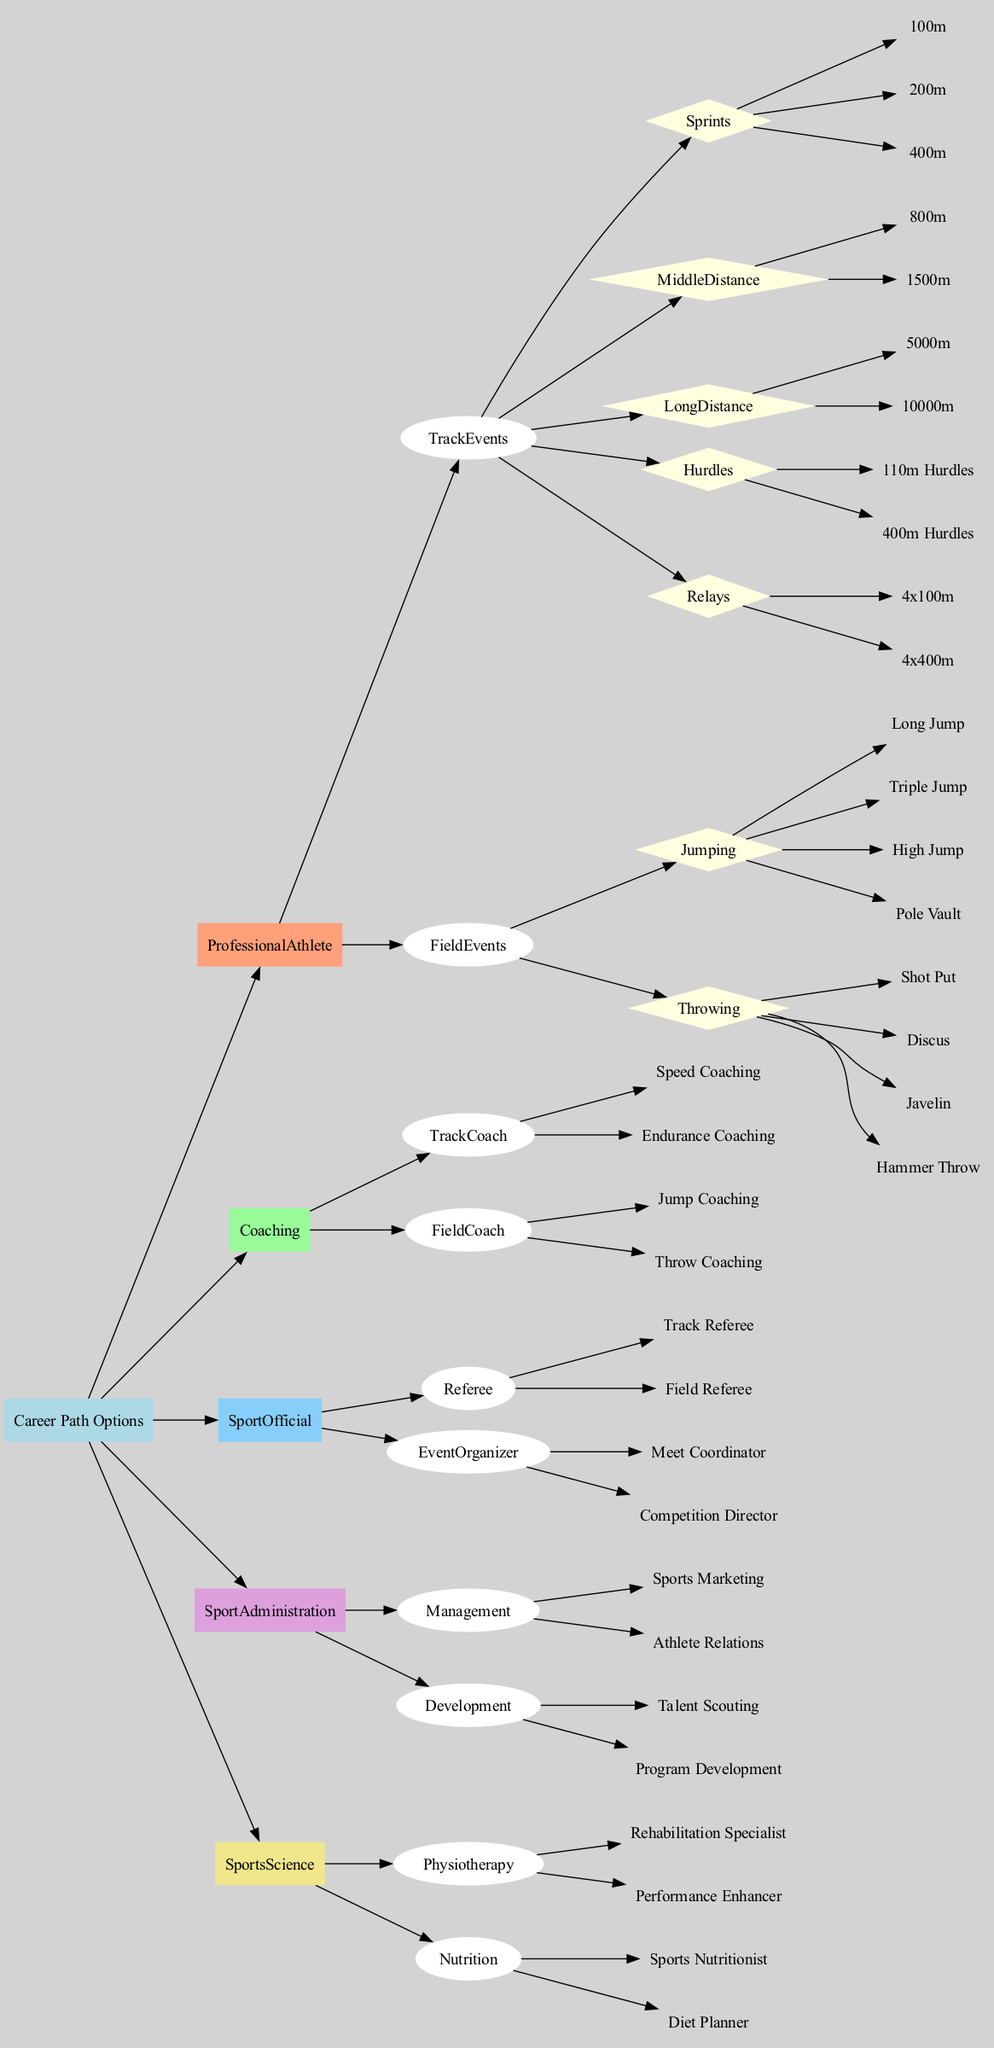What are the two main categories under Coaching? The diagram shows that under Coaching, there are two main subcategories: TrackCoach and FieldCoach. These relate to the type of coaching offered, focusing on track events and field events respectively.
Answer: TrackCoach, FieldCoach How many types of Professional Athlete events are listed? The diagram shows that Professional Athletes can participate in Track Events and Field Events. Within these categories, there are 5 types of Track events (Sprints, Middle Distance, Long Distance, Hurdles, Relays) and 2 types of Field events (Jumping, Throwing). This totals to 7 types of events.
Answer: 7 Which subcategory contains Shot Put? Shot Put is listed under the subcategory of Field Events, which specifically falls under Professional Athlete career paths. It is part of the category Throwing within Field Events.
Answer: Throwing How many specific events are listed under Sprints? The Sprints subcategory lists three specific events: 100m, 200m, and 400m. This category contains these distinct track events.
Answer: 3 Which career path includes Event Organizer? The Event Organizer role is listed under the Sport Official category, which also includes the Referee role. This categorization indicates that Event Organizer is part of the responsibilities within the official roles in sports.
Answer: Sport Official What is the total number of different coaching types? Under the Coaching category, there are 4 coaching types: Speed Coaching and Endurance Coaching under TrackCoach, and Jump Coaching and Throw Coaching under FieldCoach, totaling to 4 distinct types.
Answer: 4 What are the two main focuses of Sports Science? The diagram shows that Sports Science is divided into two main focuses: Physiotherapy and Nutrition. Each of these focuses further branches out into specific roles, emphasizing their importance in the athletic career context.
Answer: Physiotherapy, Nutrition What is the relationship between Management and Athlete Relations? Management is a subcategory under Sport Administration, and Athlete Relations is one of the specific roles listed within that subcategory. This indicates that Athlete Relations is a responsibility within the broader field of sports management.
Answer: Management 